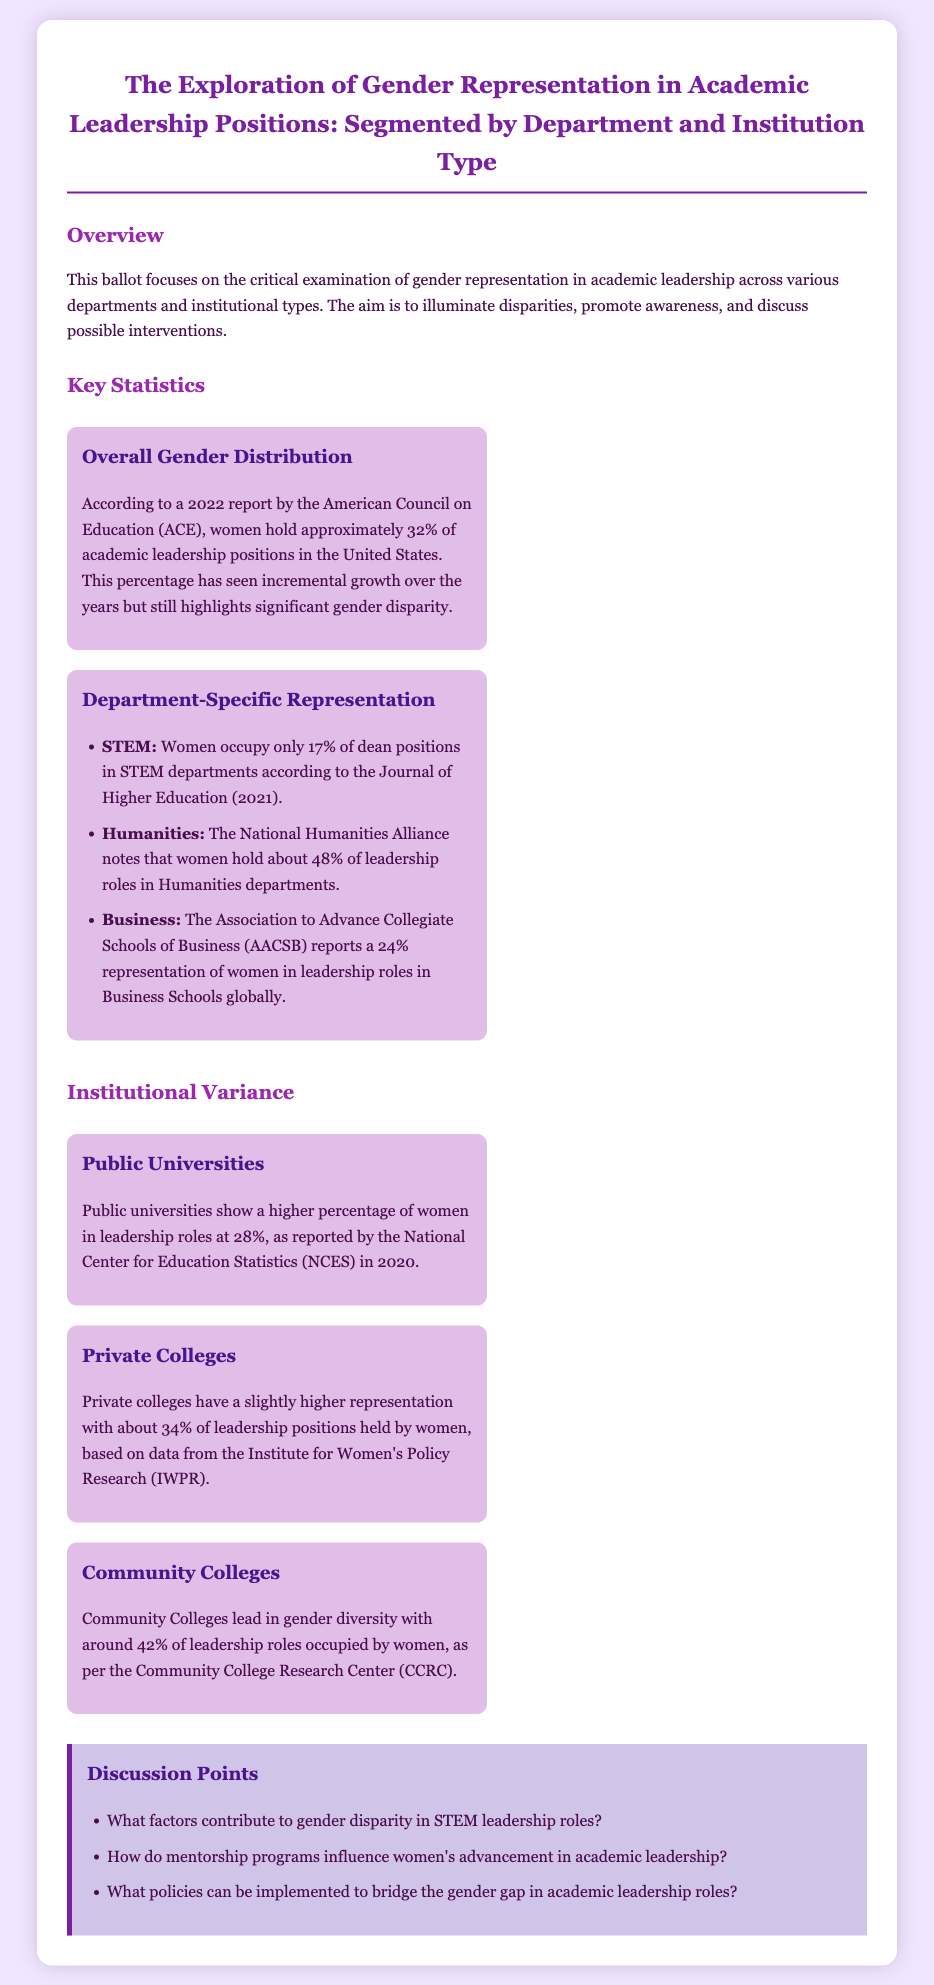what percentage of women hold academic leadership positions in the U.S.? According to the document, women hold approximately 32% of academic leadership positions in the United States.
Answer: 32% what is the representation of women in STEM dean positions? The document states that women occupy only 17% of dean positions in STEM departments.
Answer: 17% which department has the highest gender representation in leadership roles? The document mentions that Humanities departments have about 48% of leadership roles held by women.
Answer: Humanities what percentage of academic leadership positions are held by women in community colleges? The document indicates that community colleges lead with around 42% of leadership roles occupied by women.
Answer: 42% what organization reported that women hold 24% of leadership roles in Business Schools? The document states that the Association to Advance Collegiate Schools of Business (AACSB) reports this statistic.
Answer: AACSB what is one proposed intervention to bridge the gender gap in academic leadership? The document provides a discussion point that includes the implementation of new policies.
Answer: Policies what factors are mentioned as contributors to gender disparity in academic leadership? The document lists factors contributing to the disparity in STEM leadership roles as a discussion point.
Answer: Factors what is the percentage of women in leadership roles at private colleges? According to the document, private colleges have about 34% of leadership positions held by women.
Answer: 34% which report provides data on women's leadership roles at public universities? The document cites a 2020 report by the National Center for Education Statistics (NCES) for this information.
Answer: NCES 